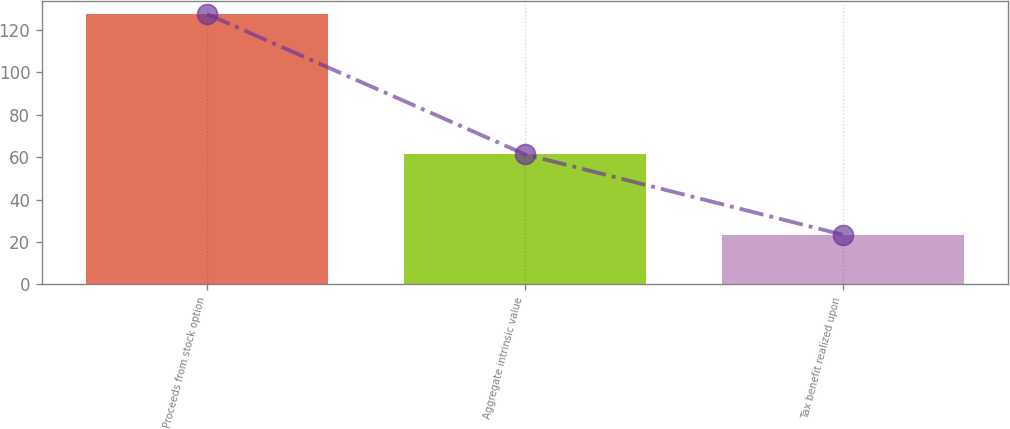Convert chart. <chart><loc_0><loc_0><loc_500><loc_500><bar_chart><fcel>Proceeds from stock option<fcel>Aggregate intrinsic value<fcel>Tax benefit realized upon<nl><fcel>127.4<fcel>61.3<fcel>23.4<nl></chart> 